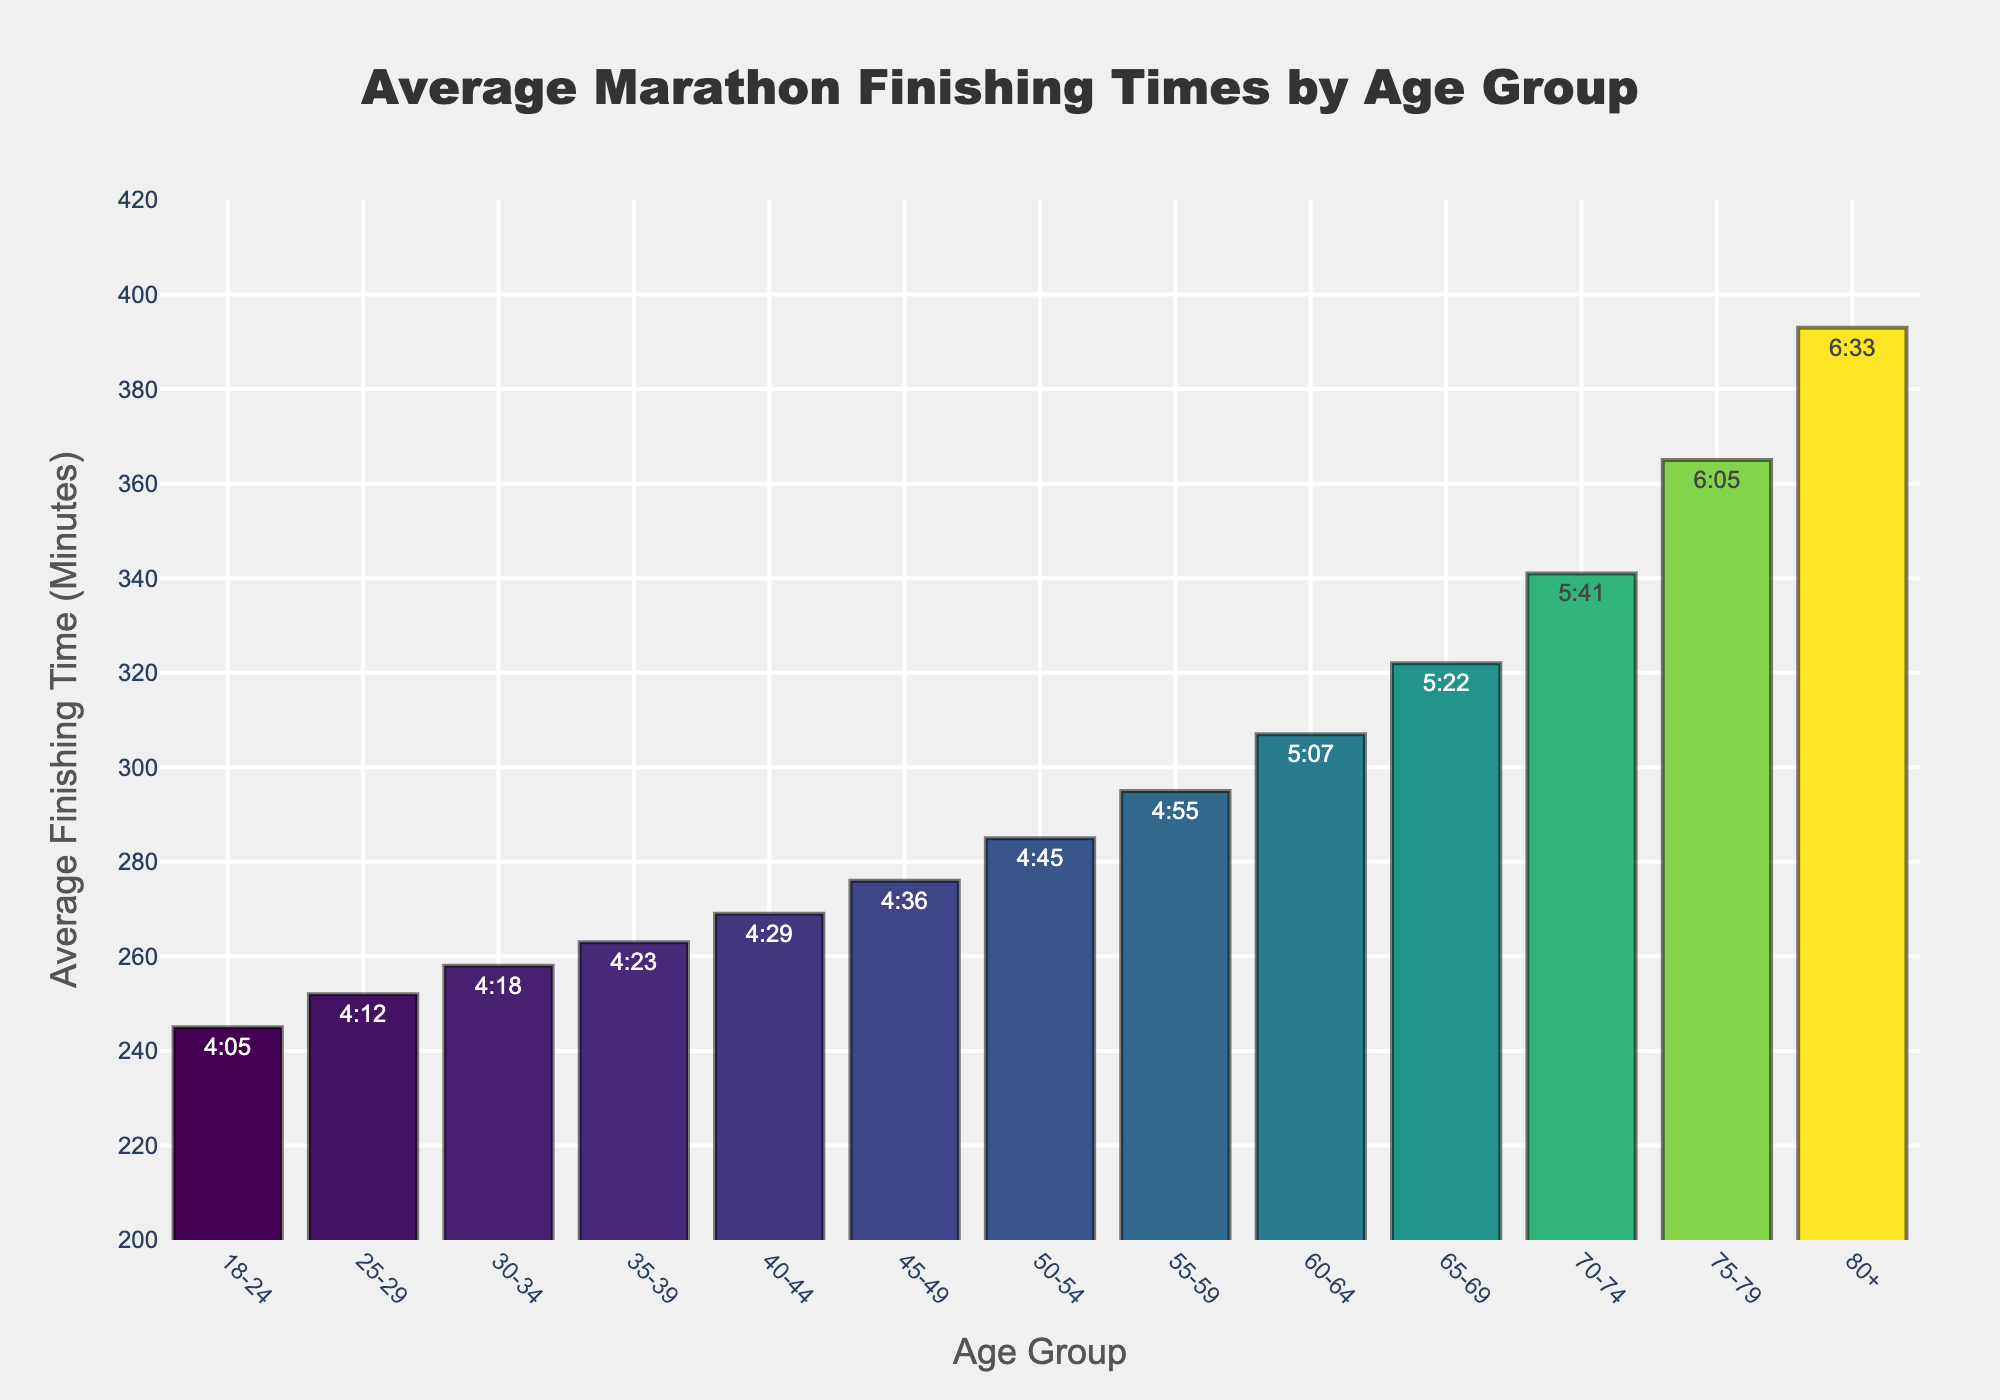What's the shortest average finishing time shown in the chart? The shortest average finishing time is found by looking for the smallest bar on the chart. The Age Group with the shortest average finishing time is 18-24, and its bar is lower than the others, with a finishing time of 4:05.
Answer: 4:05 How does the average finishing time for the 40-44 age group compare to the 45-49 age group? To compare the average finishing times, find the height of the bars corresponding to the 40-44 and 45-49 age groups. The 40-44 age group has an average finishing time of 4:29, and the 45-49 age group has 4:36. The 40-44 age group finishes faster on average.
Answer: 4:29 vs. 4:36 Which age group has the highest average finishing time in minutes? The highest average finishing time is indicated by the tallest bar in the chart. The bar for the age group 80+ is the tallest, indicating the highest average finishing time. The time is 6:33, which translates to 393 minutes.
Answer: 80+ (393 minutes) What is the difference in average finishing time between the 25-29 and 30-34 age groups? The average finishing time for the 25-29 age group is 4:12 and for the 30-34 age group is 4:18. To find the difference, subtract the smaller time from the larger time in minutes. Converting these times to minutes (252 and 258, respectively), the difference is 258 - 252 = 6 minutes.
Answer: 6 minutes What is the average finishing time for middle-aged groups (35-49)? To find the average for the 35-39, 40-44, and 45-49 groups, sum their average finishing times and divide by three. Their times are 4:23, 4:29, and 4:36, which convert to 263, 269, and 276 minutes respectively. (263 + 269 + 276) / 3 = 808 / 3 ≈ 269.3 minutes, or approximately 4:29.
Answer: 4:29 Which age groups finish the marathon in under 5 hours? Looking at the chart, the age groups finishing under 5 hours (300 minutes) are those where the bar height is less than the 300-minute mark. These groups are 18-24, 25-29, 30-34, 35-39, 40-44, 45-49, and 50-54.
Answer: 18-54 What's the average finishing time difference between the youngest (18-24) and oldest (80+) age groups? The average finishing times for 18-24 and 80+ are 4:05 and 6:33, respectively. Converting these to minutes (245 and 393), subtract the smaller from the larger. 393 - 245 = 148 minutes.
Answer: 148 minutes Which age group has a finishing time that is closest to 5 hours? Visually identify the bar whose height is closest to 300 minutes. The 55-59 age group has a time of 4:55, which is the closest to 5 hours (300 minutes), converting to 295 minutes.
Answer: 55-59 What are the visual trends in average finishing time as age increases? As age increases, the height of the bars generally increases, indicating that the average finishing time increases with age. This shows that younger age groups tend to finish faster compared to older age groups.
Answer: Increases with age How much longer does the 75-79 age group take to complete a marathon compared to the 60-64 age group? The average finishing times for the 75-79 and 60-64 age groups are 6:05 and 5:07, respectively. Converting these to minutes (365 and 307), subtract the smaller from the larger: 365 - 307 = 58 minutes.
Answer: 58 minutes 